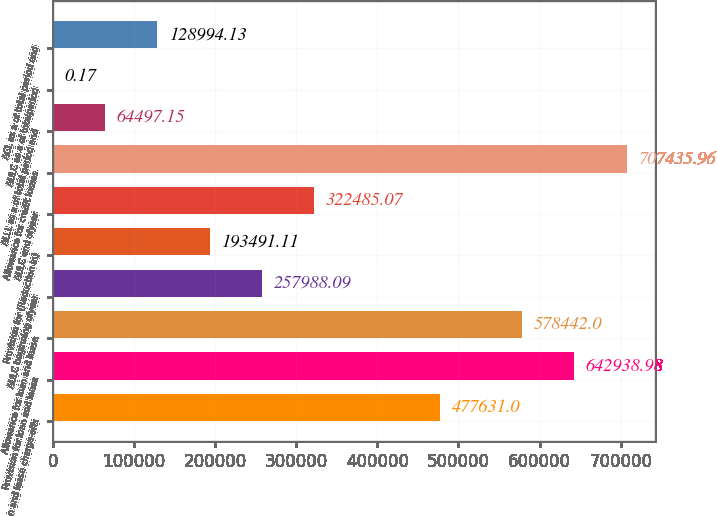Convert chart to OTSL. <chart><loc_0><loc_0><loc_500><loc_500><bar_chart><fcel>Net loan and lease charge-offs<fcel>Provision for loan and lease<fcel>Allowance for loan and lease<fcel>AULC beginning ofyear<fcel>Provision for (Reduction in)<fcel>AULC end ofyear<fcel>Allowance for credit losses<fcel>ALLL as a of total period end<fcel>AULC as a of totalperiod<fcel>ACL as a of total period end<nl><fcel>477631<fcel>642939<fcel>578442<fcel>257988<fcel>193491<fcel>322485<fcel>707436<fcel>64497.2<fcel>0.17<fcel>128994<nl></chart> 